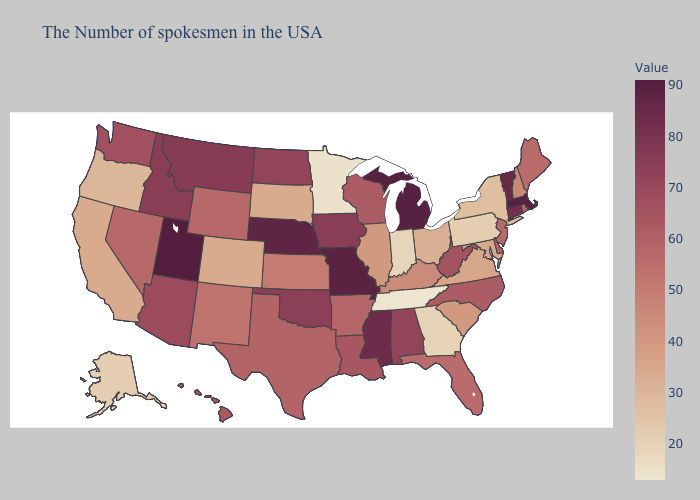Does Utah have the highest value in the West?
Write a very short answer. Yes. Does Pennsylvania have a lower value than Mississippi?
Quick response, please. Yes. Which states hav the highest value in the West?
Be succinct. Utah. Does the map have missing data?
Write a very short answer. No. 